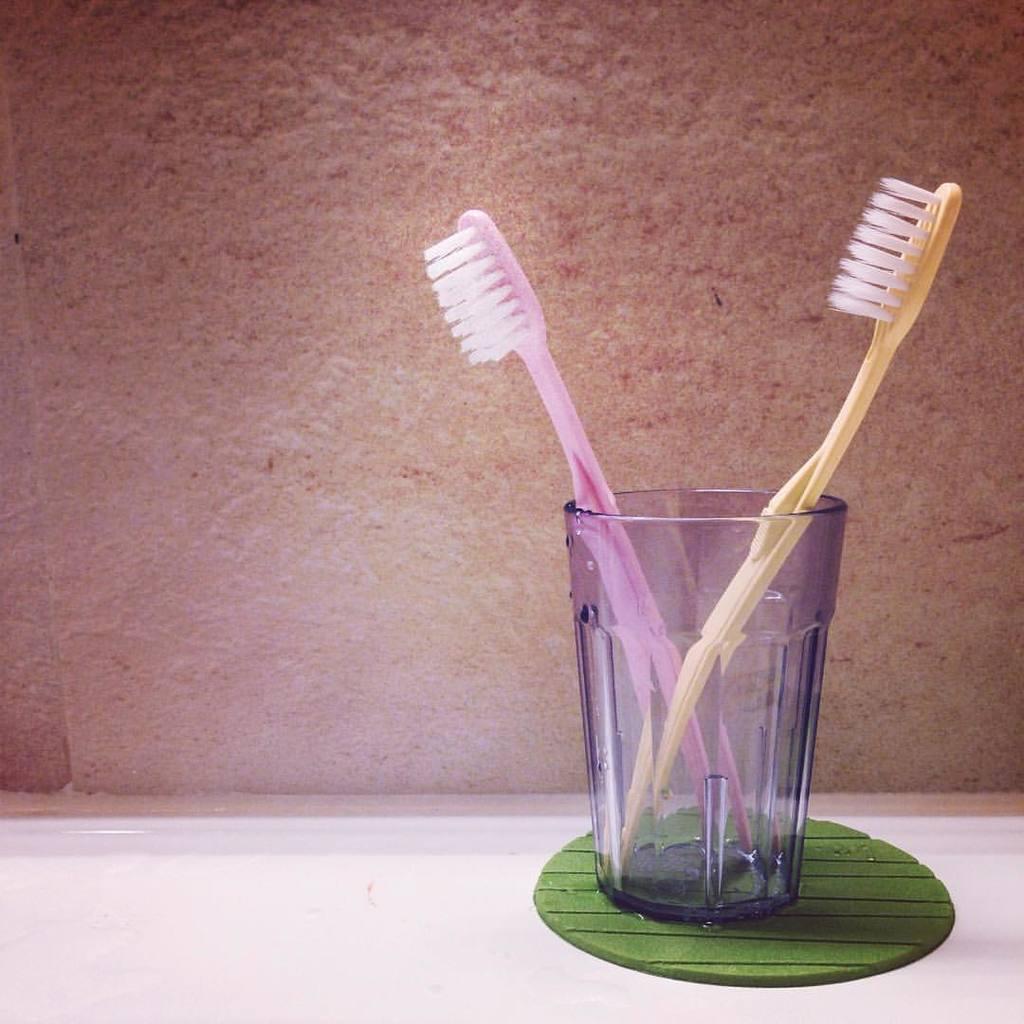Can you describe this image briefly? In the background we can see the wall. In this picture we can see a platform and on the platform we can see the tooth brushes in a glass holder. Glass is placed on an object. 